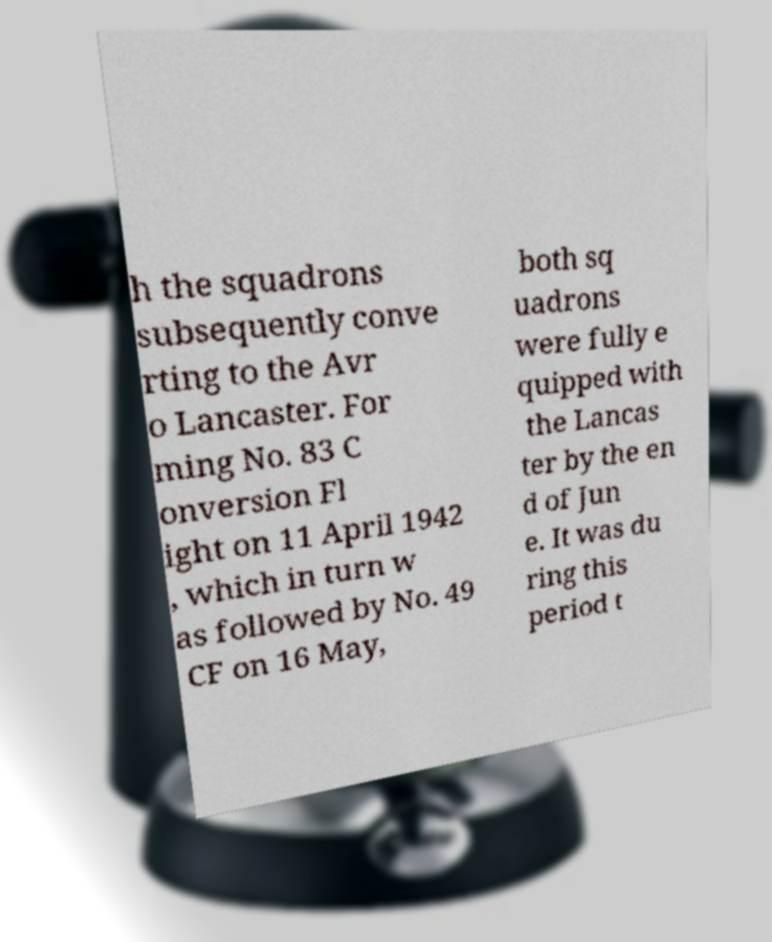Can you accurately transcribe the text from the provided image for me? h the squadrons subsequently conve rting to the Avr o Lancaster. For ming No. 83 C onversion Fl ight on 11 April 1942 , which in turn w as followed by No. 49 CF on 16 May, both sq uadrons were fully e quipped with the Lancas ter by the en d of Jun e. It was du ring this period t 